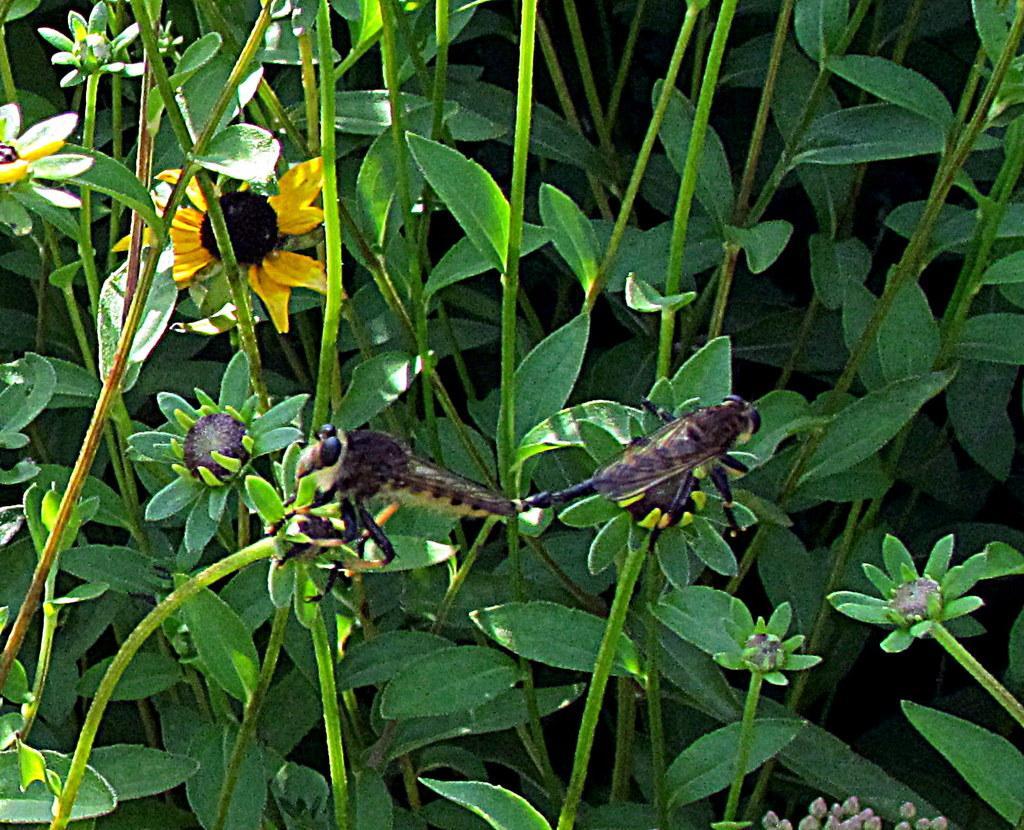How would you summarize this image in a sentence or two? In this image there are two flies eating the flowers. In the background there are plants with the sunflowers. 